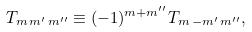Convert formula to latex. <formula><loc_0><loc_0><loc_500><loc_500>T _ { m \, m ^ { \prime } \, m ^ { \prime \prime } } \equiv ( - 1 ) ^ { m + m ^ { \prime \prime } } T _ { m \, - m ^ { \prime } \, m ^ { \prime \prime } } ,</formula> 